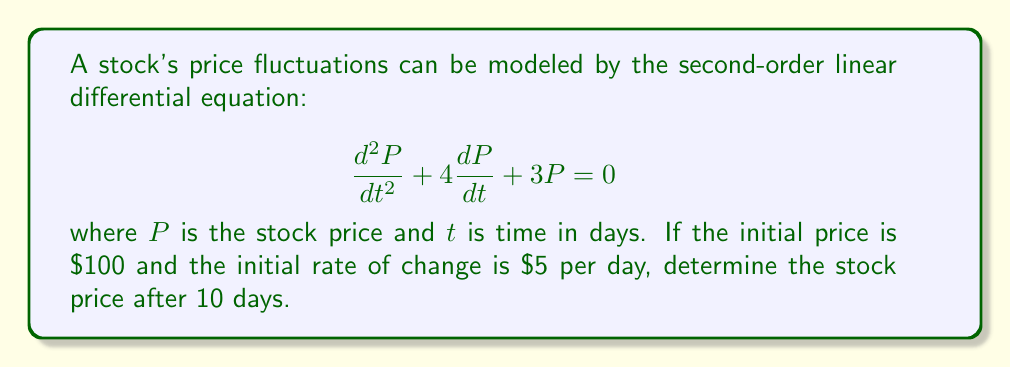Give your solution to this math problem. To solve this problem, we'll follow these steps:

1) The characteristic equation for this differential equation is:
   $$r^2 + 4r + 3 = 0$$

2) Solving this quadratic equation:
   $$r = \frac{-4 \pm \sqrt{16 - 12}}{2} = \frac{-4 \pm 2}{2}$$
   $$r_1 = -1, r_2 = -3$$

3) The general solution is therefore:
   $$P(t) = C_1e^{-t} + C_2e^{-3t}$$

4) We need to use the initial conditions to find $C_1$ and $C_2$:
   At $t=0$, $P(0) = 100$, so:
   $$100 = C_1 + C_2 \quad (1)$$

   Also, $\frac{dP}{dt}(0) = 5$, so:
   $$5 = -C_1 - 3C_2 \quad (2)$$

5) Solving equations (1) and (2):
   From (2): $C_1 = -5 - 3C_2$
   Substituting into (1):
   $$100 = (-5 - 3C_2) + C_2$$
   $$100 = -5 - 2C_2$$
   $$C_2 = -52.5$$
   Then, $C_1 = -5 - 3(-52.5) = 152.5$

6) Therefore, the particular solution is:
   $$P(t) = 152.5e^{-t} - 52.5e^{-3t}$$

7) To find the price after 10 days, we evaluate $P(10)$:
   $$P(10) = 152.5e^{-10} - 52.5e^{-30}$$
   $$= 152.5(0.0000454) - 52.5(9.36 \times 10^{-14})$$
   $$\approx 0.00692 - 0.00000$$
   $$\approx 0.00692$$
Answer: The stock price after 10 days is approximately $\$0.01$ (rounded to the nearest cent). 